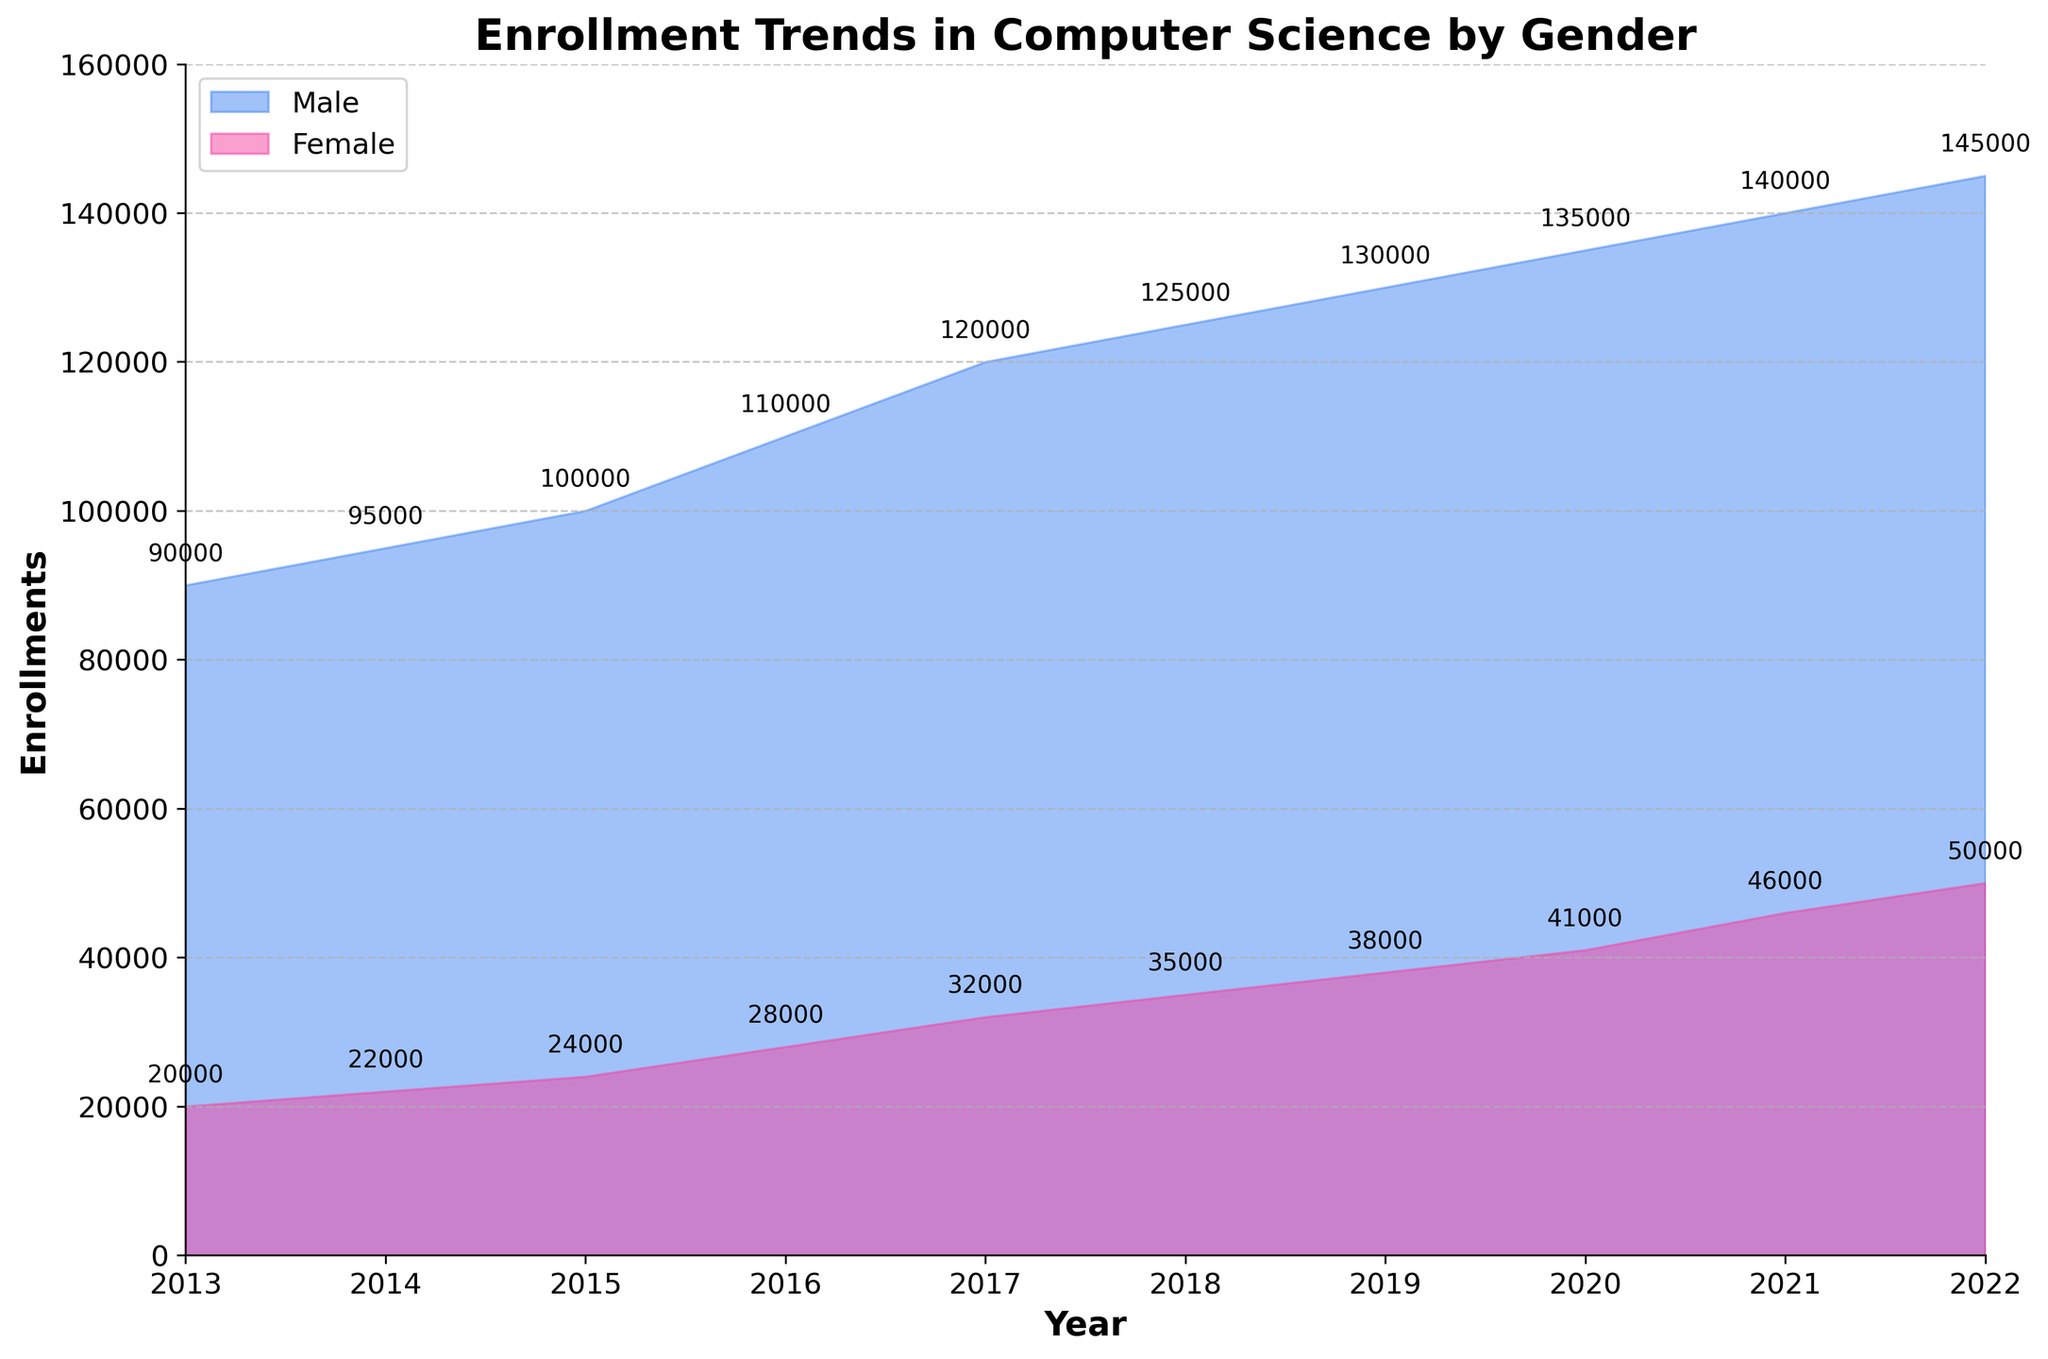what is the title of the figure? The title is located at the top center of the figure and highlights the main topic or subject of the chart. In this case, the title indicates the subject is Enrollment Trends in Computer Science by Gender.
Answer: Enrollment Trends in Computer Science by Gender which gender has higher enrollments in 2020? By examining the area sizes near the vertical line corresponding to the year 2020 on the chart, you can compare the male and female enrollments. The area representing male enrollments is significantly larger.
Answer: Male how have female enrollments changed from 2013 to 2022? Look at the lower filled area from the start year 2013 to the end year 2022. The female enrollments start at 20,000 in 2013 and rise steadily to 50,000 by 2022.
Answer: Increased by 30,000 what is the total number of enrollments in 2016? Sum the male and female enrollment numbers for the year 2016. Therefore, 110,000 (male) + 28,000 (female) = 138,000
Answer: 138,000 which year shows the highest female enrollment? Look at the highest point of the area representing female enrollments and check the corresponding year on the x-axis. This peak occurs in 2022.
Answer: 2022 by how much did male enrollments increase from 2015 to 2017? Subtract the number of male enrollments in the year 2015 from that in 2017. Therefore, 120,000 - 100,000 = 20,000
Answer: 20,000 what is the rate of increase in female enrollments from 2018 to 2020? Calculate the difference in female enrollments between 2020 and 2018, and divide by the number of years between them. (41,000 - 35,000) / (2020 - 2018) = 6,000 / 2 = 3,000 enrollments per year.
Answer: 3,000 enrollments per year how does the trend in male enrollments compare to that of female enrollments over the decade? Observe the general shape and direction of both filled areas over the years. Both male and female enrollments show an increasing trend, but male enrollments start higher and have a larger volume increase over the time span.
Answer: Both increase, males increase more what were the female enrollments in 2017? Find the point where the female area intersects with the vertical line for the year 2017. This point indicates the number of enrollments, which is 32,000.
Answer: 32,000 are the enrollments more stable in any particular gender? Compare the smoothness of the lines for both male and female enrollment areas. Male enrollments increase steadily without large fluctuations, indicating more stability compared to the female enrollments.
Answer: Male how many years saw an increase in female enrollments? Count the number of years in which female enrollments in a year are higher than the previous year. Female enrollments increased every year from 2013 to 2022.
Answer: 9 